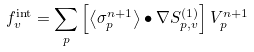Convert formula to latex. <formula><loc_0><loc_0><loc_500><loc_500>f _ { v } ^ { \text {int} } = \sum _ { p } \left [ \left < \sigma _ { p } ^ { n + 1 } \right > \bullet \nabla S ^ { ( 1 ) } _ { p , v } \right ] V _ { p } ^ { n + 1 }</formula> 